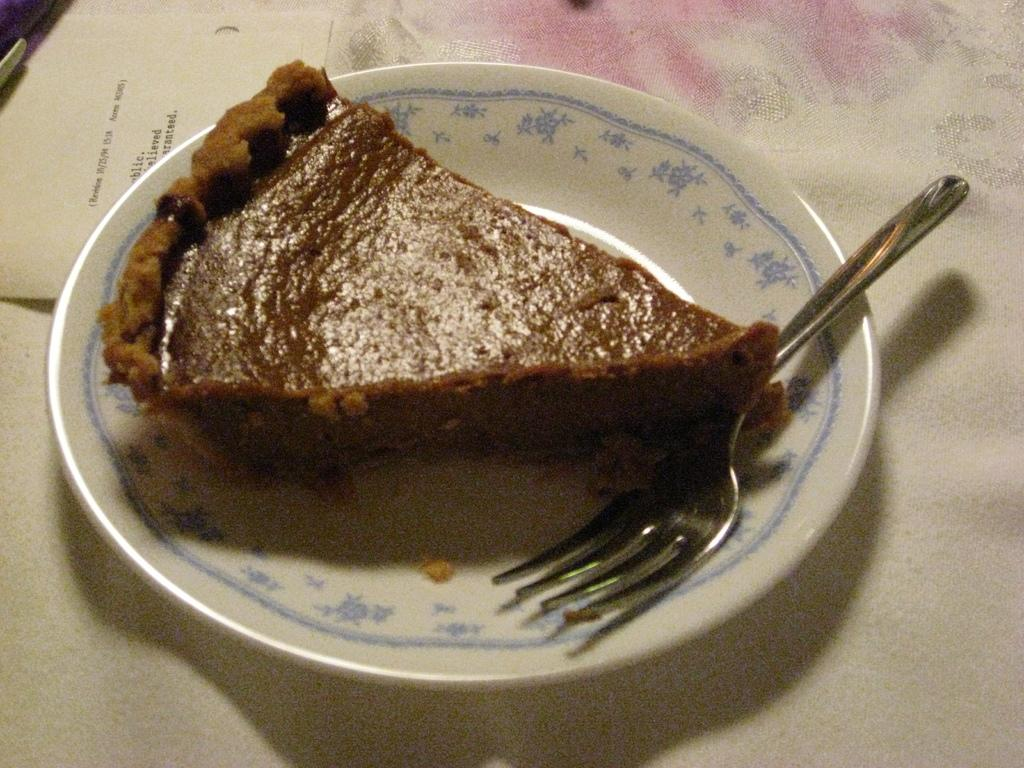What type of dish is visible in the image? There is a plated dish in the image. What dessert is featured on the plate? There is a cake on the plate. What utensil is present in the image? There is a fork in the image. What type of paper is visible in the image? There is a paper in the image. Where are all these objects located? All of these objects are on a platform. What type of powder is sprinkled on the cake in the image? There is no powder visible on the cake in the image. Can you see a comb being used to style someone's hair in the image? There is no comb present in the image. 